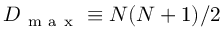<formula> <loc_0><loc_0><loc_500><loc_500>D _ { m a x } \equiv N ( N + 1 ) / 2</formula> 